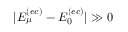<formula> <loc_0><loc_0><loc_500><loc_500>| E _ { \mu } ^ { ( e c ) } - E _ { 0 } ^ { ( e c ) } | \gg 0</formula> 